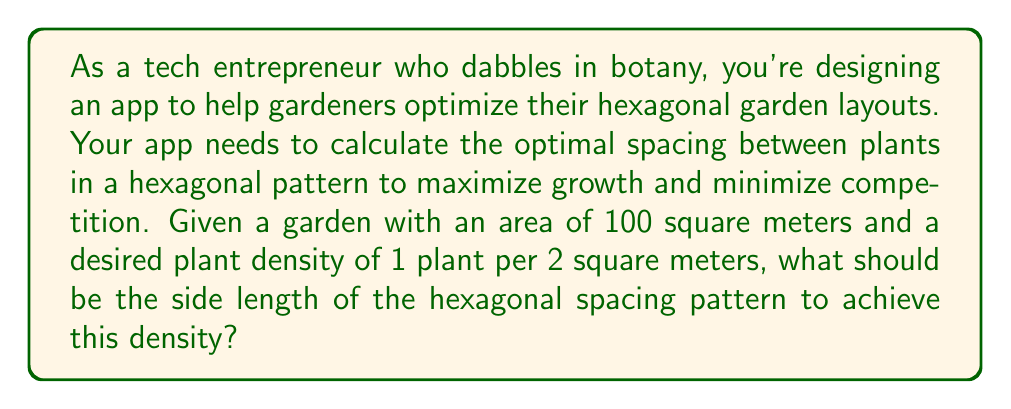Show me your answer to this math problem. Let's approach this step-by-step:

1) In a hexagonal pattern, each plant occupies the center of a regular hexagon. The area of this hexagon represents the space allocated to each plant.

2) Given:
   - Total garden area: $A_t = 100 \text{ m}^2$
   - Desired density: 1 plant per 2 $\text{m}^2$
   - Number of plants: $N = A_t \div 2 = 50$ plants

3) Area of each hexagon (space per plant):
   $A_h = 2 \text{ m}^2$

4) The area of a regular hexagon with side length $s$ is given by:
   $$A_h = \frac{3\sqrt{3}}{2}s^2$$

5) Substituting our known $A_h$:
   $$2 = \frac{3\sqrt{3}}{2}s^2$$

6) Solving for $s$:
   $$s^2 = \frac{4}{3\sqrt{3}}$$
   $$s = \sqrt{\frac{4}{3\sqrt{3}}} = \sqrt{\frac{4\sqrt{3}}{9}} \approx 0.8205 \text{ m}$$

7) To visualize:

[asy]
unitsize(50);
pair[] hex = {dir(0), dir(60), dir(120), dir(180), dir(240), dir(300)};
for(int i = 0; i < 6; ++i) {
  draw(hex[i]--hex[(i+1)%6]);
}
dot((0,0));
label("$s$", (0.5,0), S);
[/asy]

This hexagonal layout ensures optimal spacing between plants, maximizing their growth potential while maintaining the desired density.
Answer: The optimal side length of the hexagonal spacing pattern is approximately 0.8205 meters or 82.05 centimeters. 